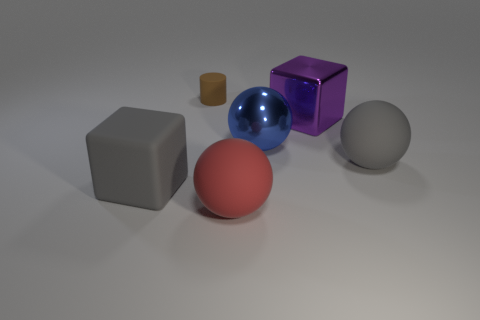Add 3 yellow cylinders. How many objects exist? 9 Subtract all blocks. How many objects are left? 4 Subtract all gray things. Subtract all blue objects. How many objects are left? 3 Add 6 big blue metallic balls. How many big blue metallic balls are left? 7 Add 5 rubber cylinders. How many rubber cylinders exist? 6 Subtract 0 red cylinders. How many objects are left? 6 